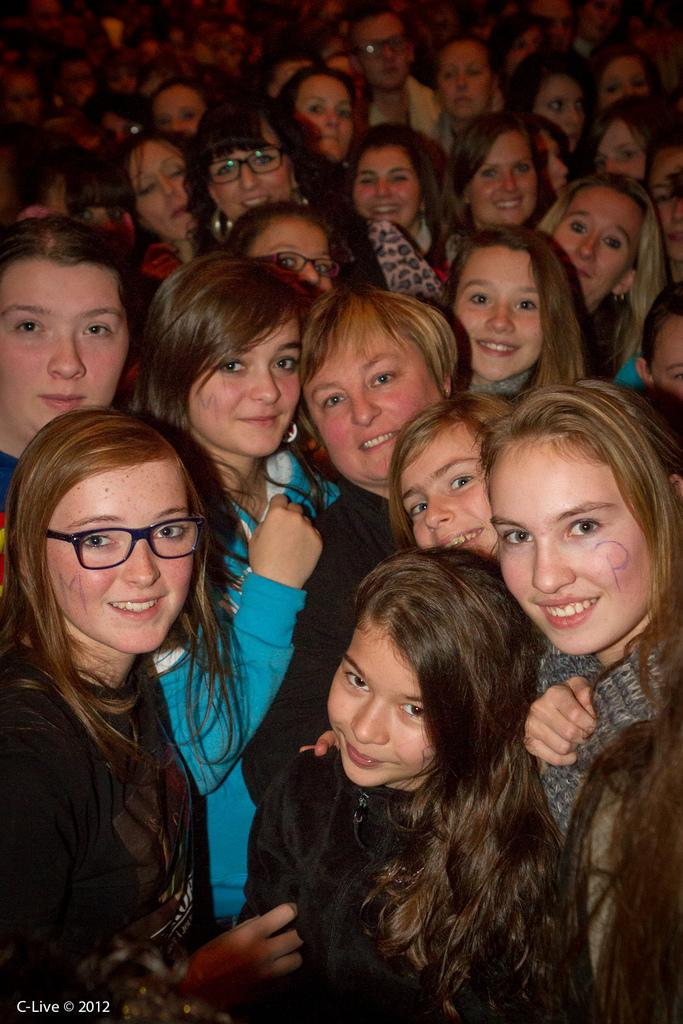What is the main subject of the image? The main subject of the image is a group of ladies. Can you describe the appearance of the ladies? The ladies are beautiful and smiling. Is there any text or marking on the image? Yes, there is a watermark at the bottom of the image. Can you tell me how many giraffes are standing behind the ladies in the image? There are no giraffes present in the image; it features a group of ladies. What type of loaf is being held by one of the ladies in the image? There is no loaf present in the image; the ladies are not holding any objects. 